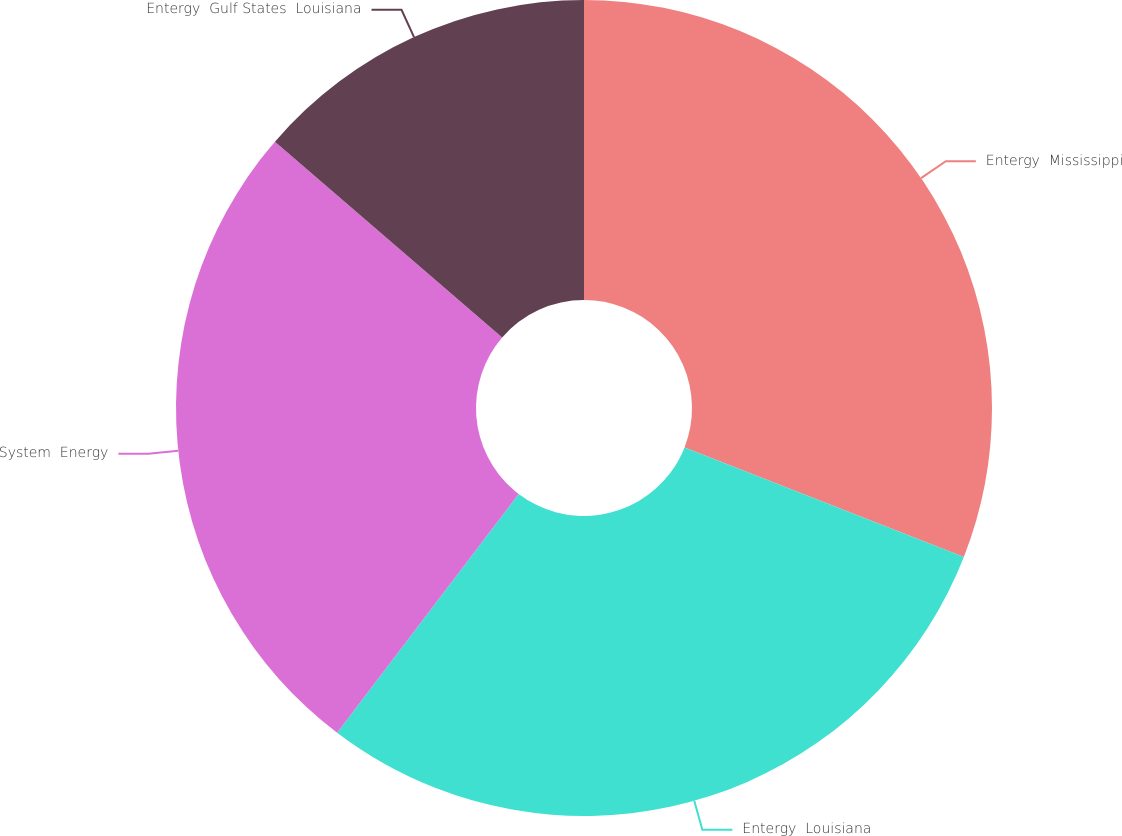Convert chart to OTSL. <chart><loc_0><loc_0><loc_500><loc_500><pie_chart><fcel>Entergy  Mississippi<fcel>Entergy  Louisiana<fcel>System  Energy<fcel>Entergy  Gulf States  Louisiana<nl><fcel>30.95%<fcel>29.4%<fcel>25.98%<fcel>13.68%<nl></chart> 